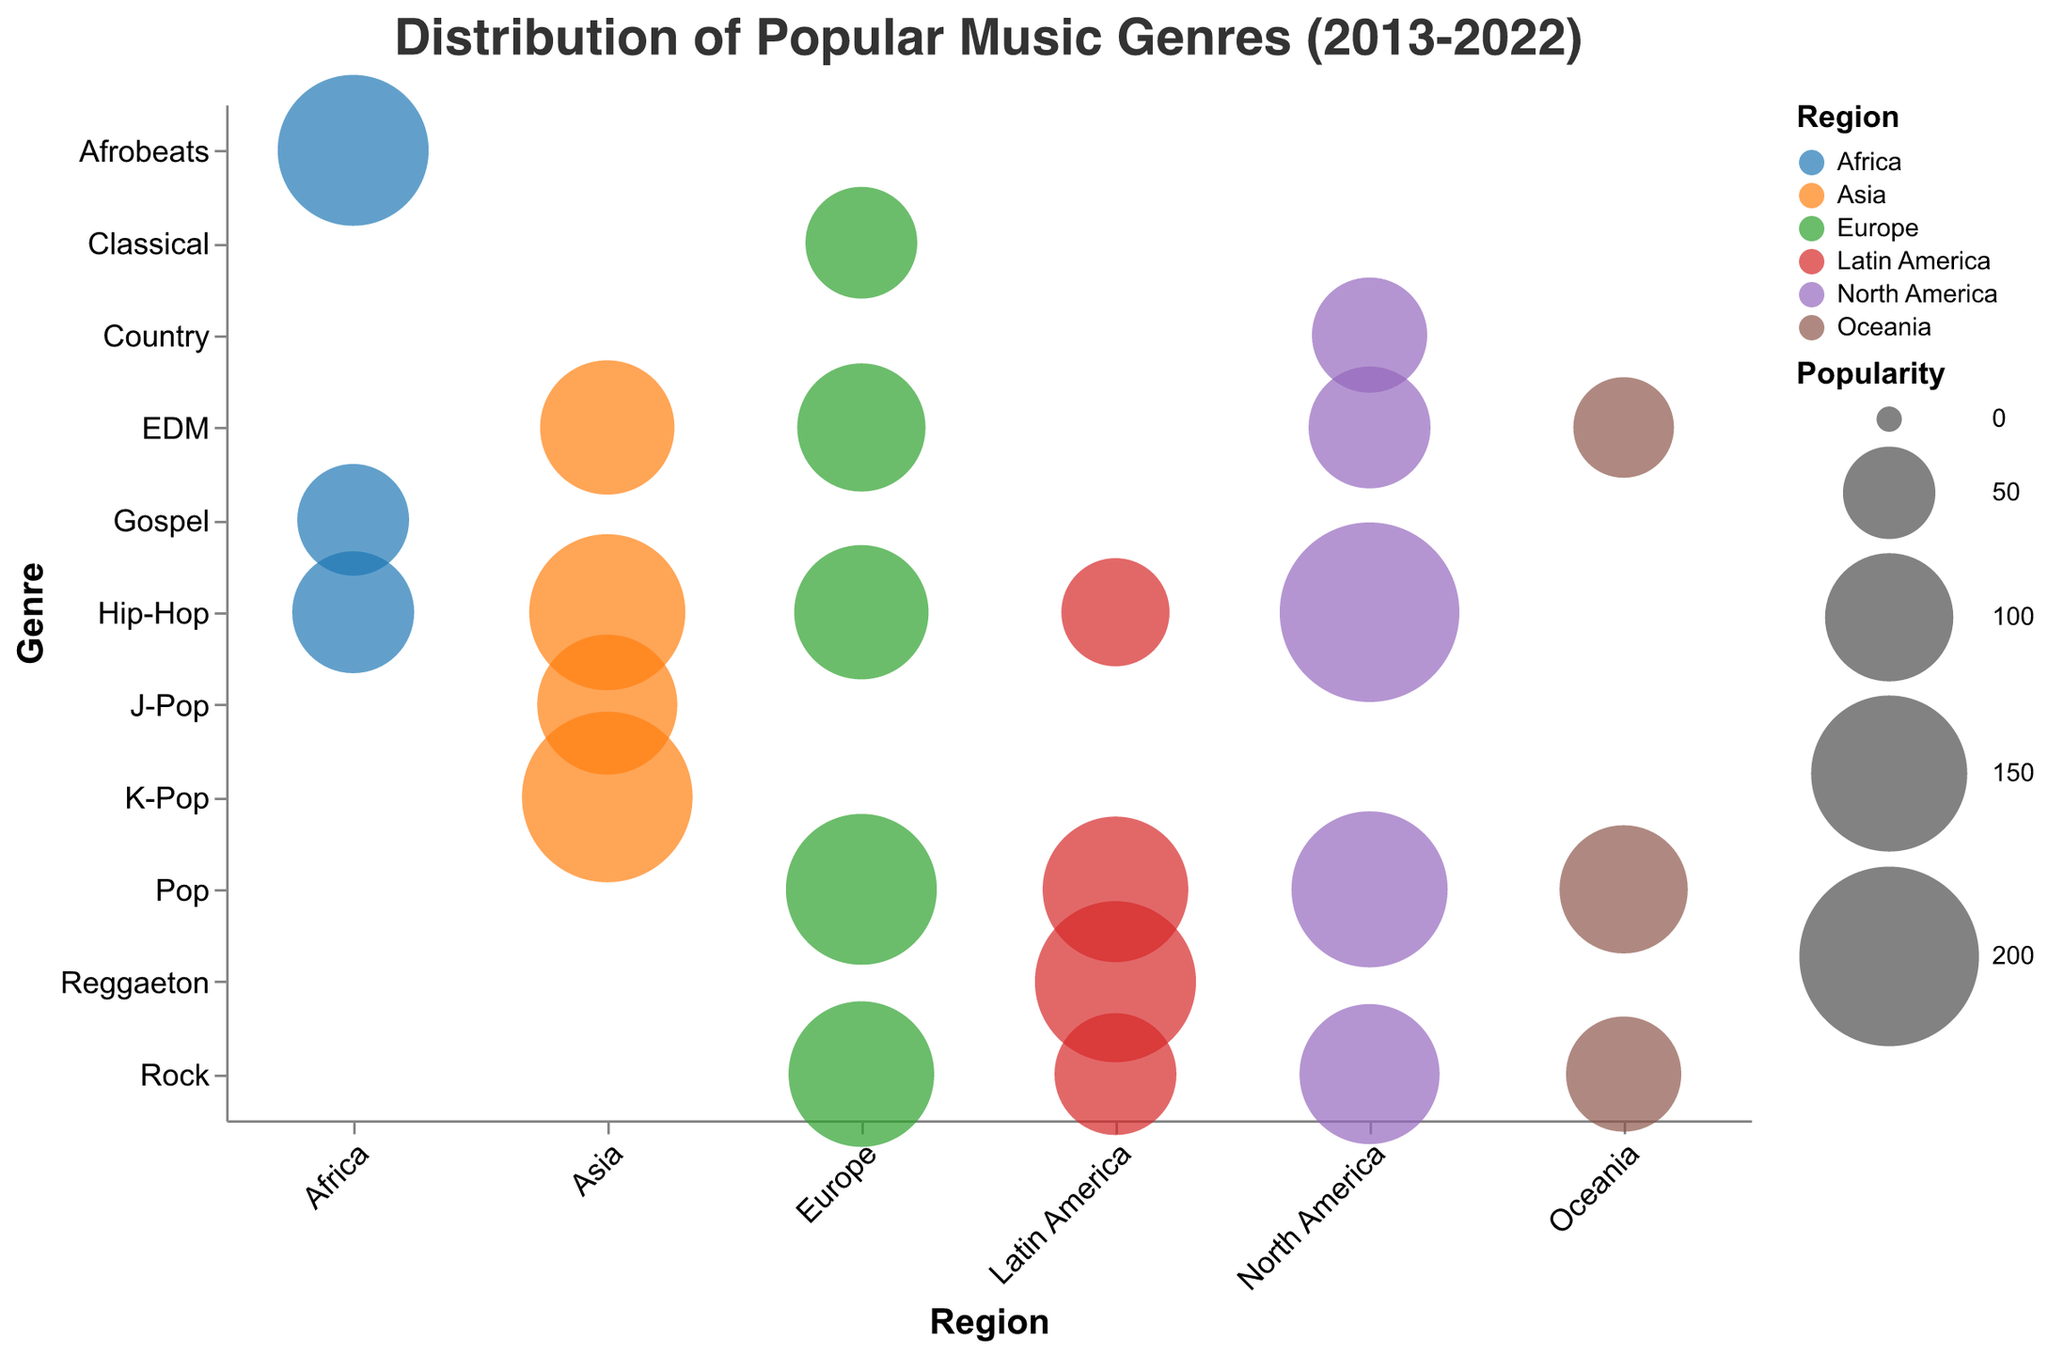What is the most popular genre in North America? The size of the bubble representing Hip-Hop in North America is the largest, indicating it is the most popular genre in that region with a bubble size of 200.
Answer: Hip-Hop Which region has the largest bubble size for Pop music? By comparing the bubble sizes for Pop music across different regions, North America has the largest bubble size of 150.
Answer: North America Compare the popularity of EDM in North America and EDM in Europe. Which one is more popular? The bubble size for EDM in North America is 90, while in Europe it is 100. Since 100 is greater than 90, EDM is more popular in Europe.
Answer: Europe What is the total popularity of Hip-Hop across all regions? Sum the bubble sizes for Hip-Hop in North America (200), Europe (110), Asia (150), Latin America (70), and Africa (90). The total is 200 + 110 + 150 + 70 + 90 = 620.
Answer: 620 Which genre has the smallest bubble size in Africa? The bubble sizes in Africa are 140 for Afrobeats, 90 for Hip-Hop, and 75 for Gospel. The smallest bubble size is 75 for Gospel.
Answer: Gospel How does the popularity of Rock music in Europe compare to Rock music in Latin America? The bubble size for Rock music in Europe is 130, and in Latin America, it is 90. Since 130 is greater than 90, Rock is more popular in Europe.
Answer: Europe Which region has the highest number of different popular genres represented? North America and Europe both have the highest number of different genres represented, each with five distinct genres.
Answer: North America and Europe What is the average bubble size for Pop music across all regions? Add the bubble sizes for Pop music in North America (150), Europe (140), Asia (180), Latin America (130), and Oceania (100). The total is 150 + 140 + 180 + 130 + 100 = 700. There are 5 regions, so the average is 700 / 5 = 140.
Answer: 140 Is Classical music represented in the data for any region other than Europe? By reviewing the genres and regions, Classical music only appears in Europe with a bubble size of 75. No other region includes Classical music.
Answer: No 